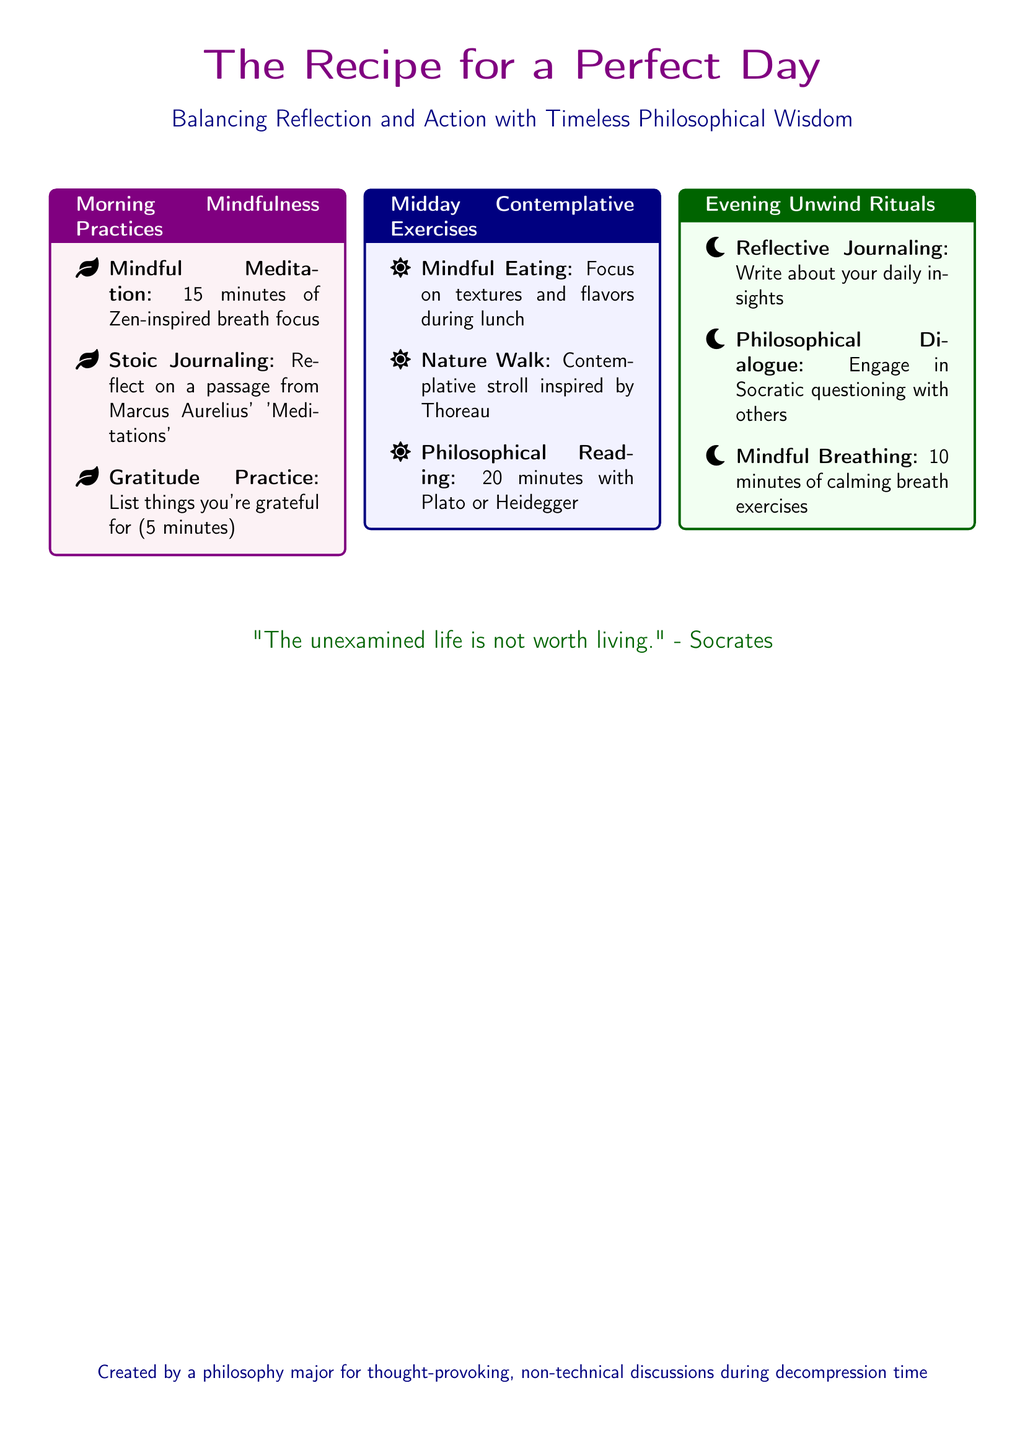What is the title of the recipe? The title of the recipe is prominently displayed at the top of the document.
Answer: The Recipe for a Perfect Day Who wrote the quote at the bottom? The quote attributed to Socrates is included in the document.
Answer: Socrates How long is the mindful meditation practice? The duration of the mindful meditation practice is specified in the morning mindfulness section.
Answer: 15 minutes What activity is suggested for the midday contemplative exercise? This exercise entails a mindful engagement with food during lunchtime.
Answer: Mindful Eating What is the color theme of the morning mindfulness practices box? The color used for the morning mindfulness practices box is stated in the document.
Answer: Purple How many items are listed under evening unwind rituals? The document enumerates the activities included in the evening unwind rituals section.
Answer: Three Which philosopher's work is suggested for midday reading? The document recommends reading a specific philosopher during the midday contemplative exercises.
Answer: Plato or Heidegger What type of questioning is encouraged during evening dialogues? The document specifies the method of questioning suggested for philosophical dialogue.
Answer: Socratic questioning What is the purpose of the recipe card? The document describes the creator's intention for the recipe card.
Answer: Thought-provoking, non-technical discussions during decompression time 